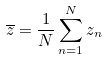Convert formula to latex. <formula><loc_0><loc_0><loc_500><loc_500>\overline { z } = \frac { 1 } { N } \sum _ { n = 1 } ^ { N } z _ { n }</formula> 